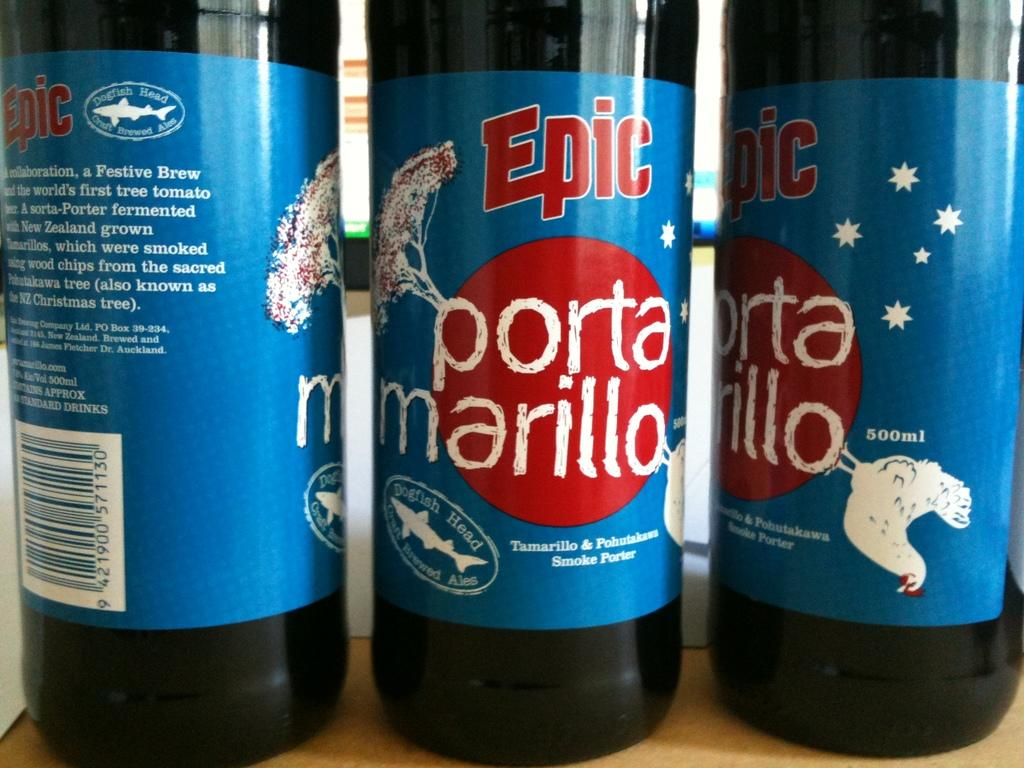<image>
Offer a succinct explanation of the picture presented. Three Epic bottles stand upright next to one another 